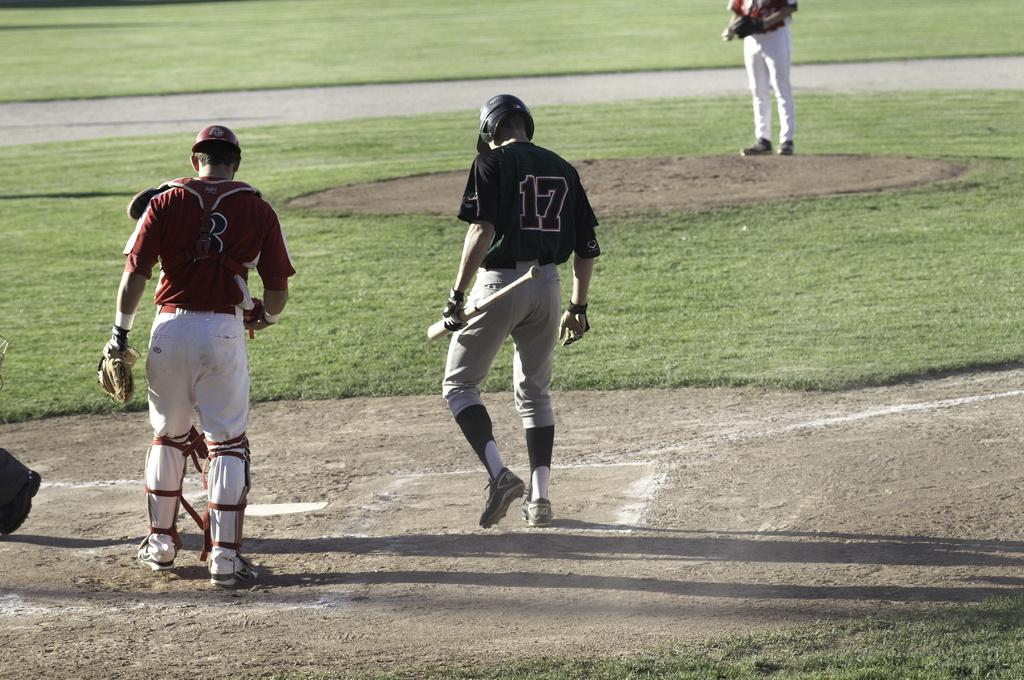<image>
Write a terse but informative summary of the picture. a player in the box with the number 17 on them 